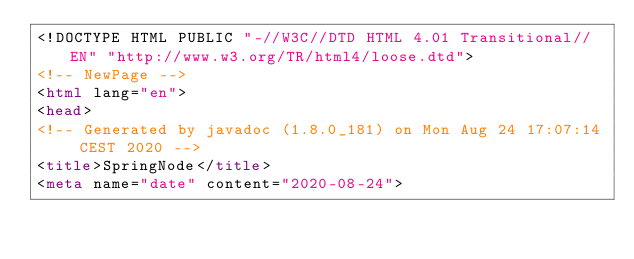<code> <loc_0><loc_0><loc_500><loc_500><_HTML_><!DOCTYPE HTML PUBLIC "-//W3C//DTD HTML 4.01 Transitional//EN" "http://www.w3.org/TR/html4/loose.dtd">
<!-- NewPage -->
<html lang="en">
<head>
<!-- Generated by javadoc (1.8.0_181) on Mon Aug 24 17:07:14 CEST 2020 -->
<title>SpringNode</title>
<meta name="date" content="2020-08-24"></code> 